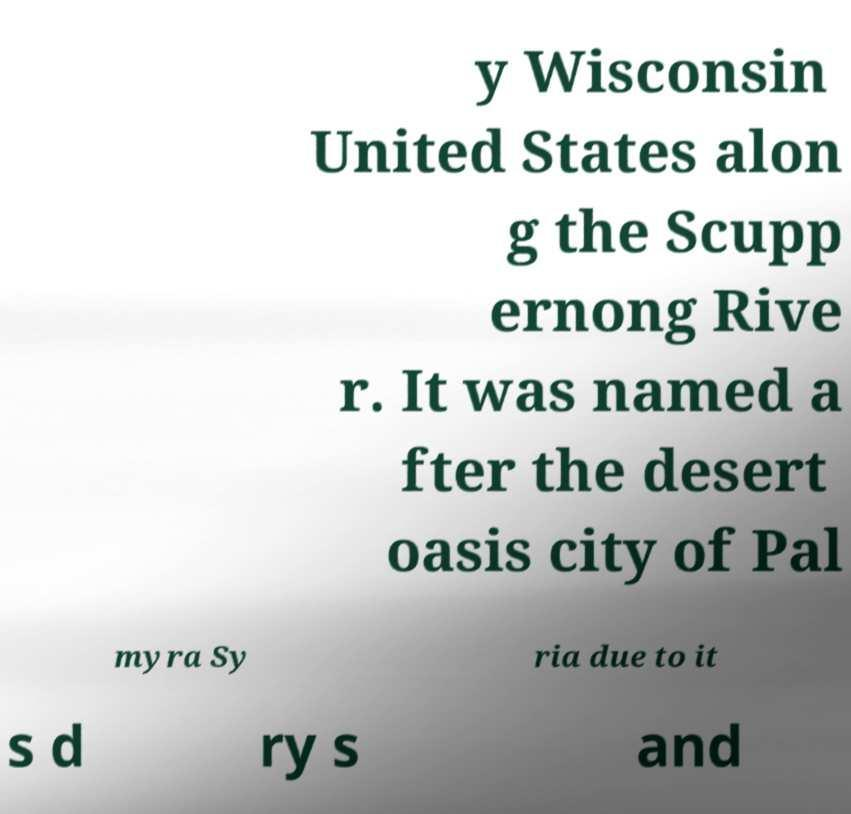What messages or text are displayed in this image? I need them in a readable, typed format. y Wisconsin United States alon g the Scupp ernong Rive r. It was named a fter the desert oasis city of Pal myra Sy ria due to it s d ry s and 